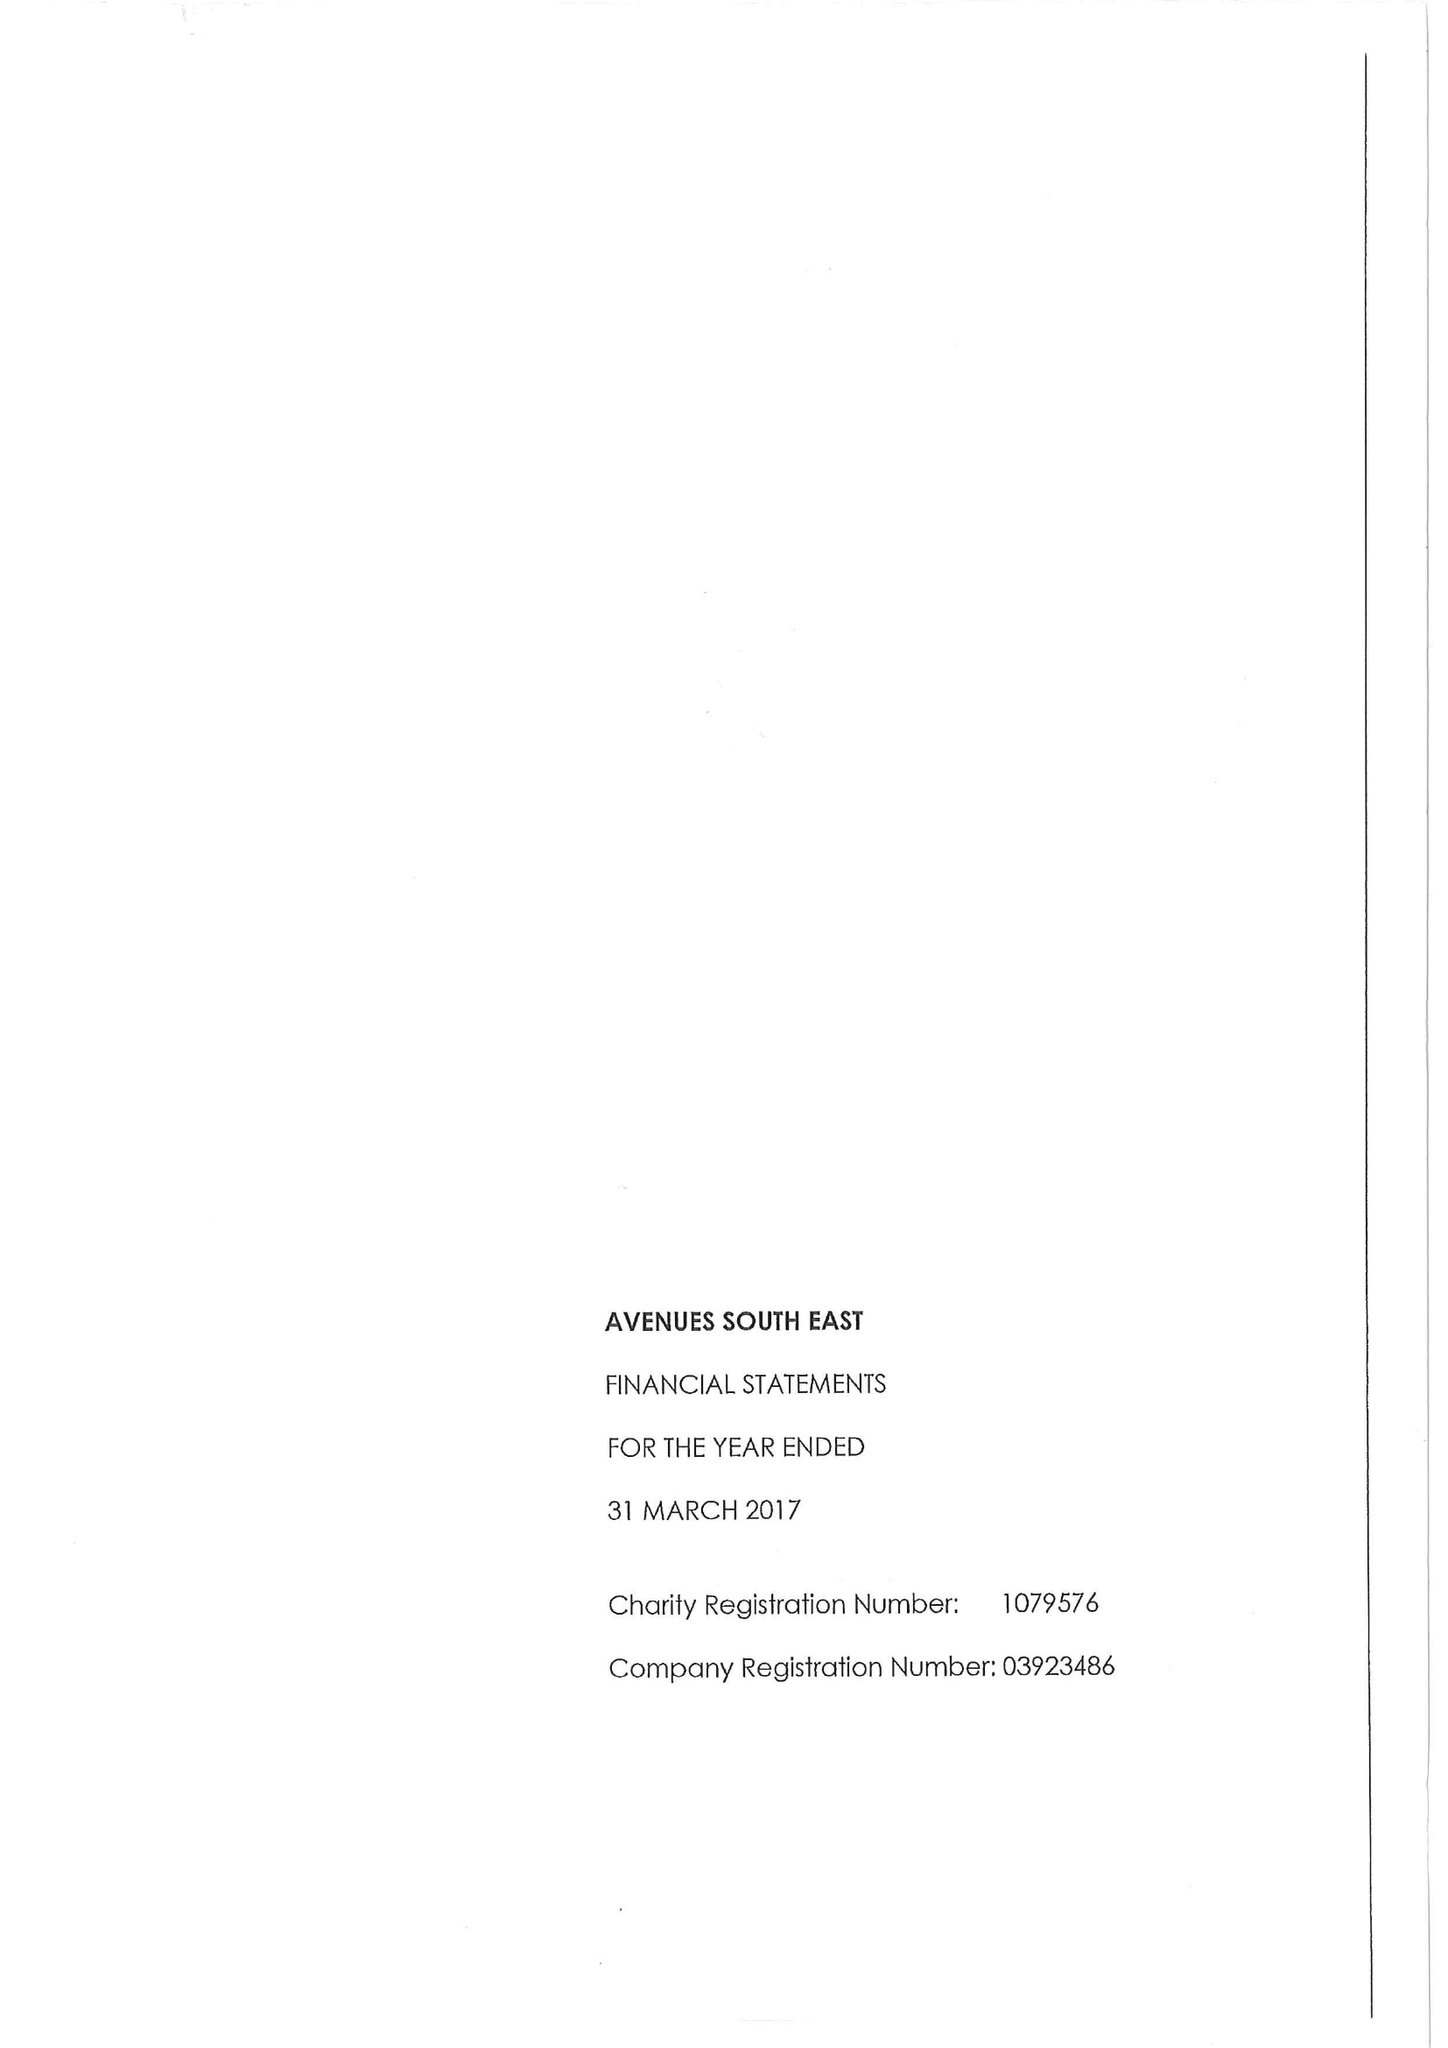What is the value for the address__street_line?
Answer the question using a single word or phrase. 1 MAIDSTONE ROAD 